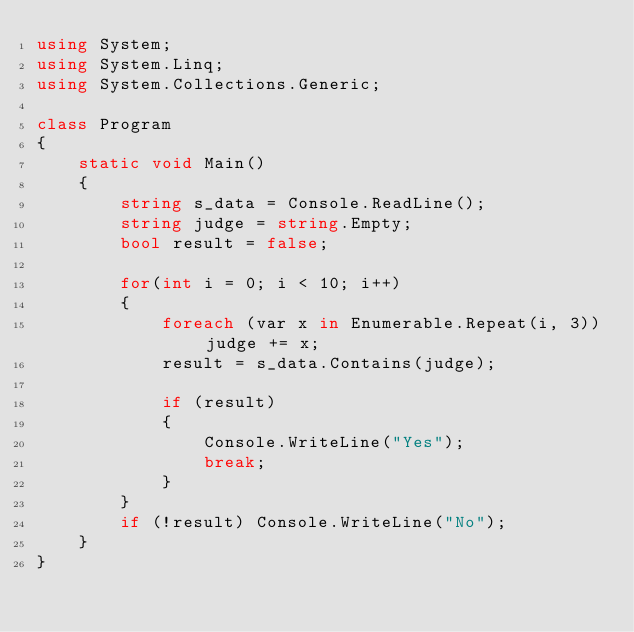Convert code to text. <code><loc_0><loc_0><loc_500><loc_500><_C#_>using System;
using System.Linq;
using System.Collections.Generic;

class Program
{
    static void Main()
    {
        string s_data = Console.ReadLine();
        string judge = string.Empty;
        bool result = false;

        for(int i = 0; i < 10; i++)
        {
            foreach (var x in Enumerable.Repeat(i, 3)) judge += x;
            result = s_data.Contains(judge);

            if (result)
            {
                Console.WriteLine("Yes");
                break;
            }
        }
        if (!result) Console.WriteLine("No");
    }
}</code> 